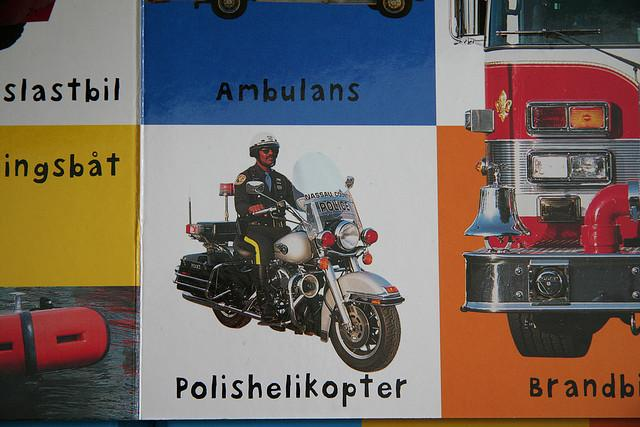What is the profession of the man on a motorcycle? Please explain your reasoning. officer. A man in a police uniform is on a motorcycle. police use motorcycles sometimes. 